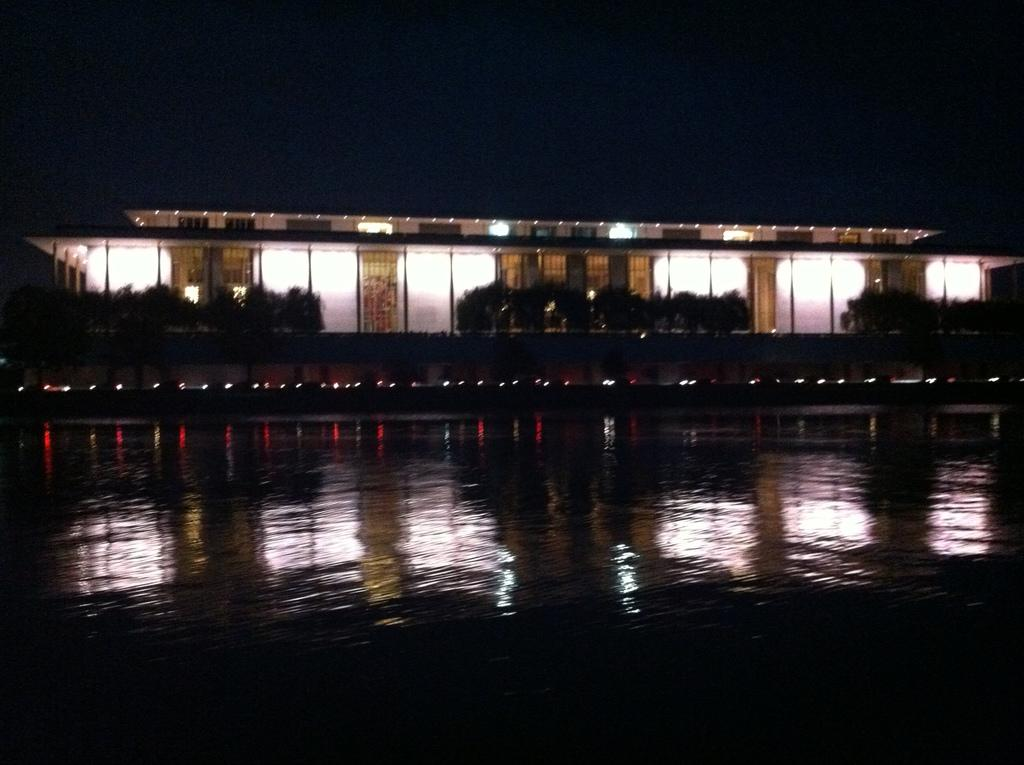What is the primary element visible in the image? There is water in the image. What can be seen in the distance behind the water? There are trees and a building in the background of the image. How are the lights arranged in the background? The lights are arranged in the background. What is the appearance of the building in the background? The building is decorated with lights. What is the overall color of the background in the image? The background is dark in color. Where is the shop located in the image? There is no shop present in the image. What type of laborer can be seen working near the water in the image? There are no laborers present in the image. 